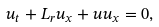<formula> <loc_0><loc_0><loc_500><loc_500>u _ { t } + L _ { r } u _ { x } + u u _ { x } = 0 ,</formula> 